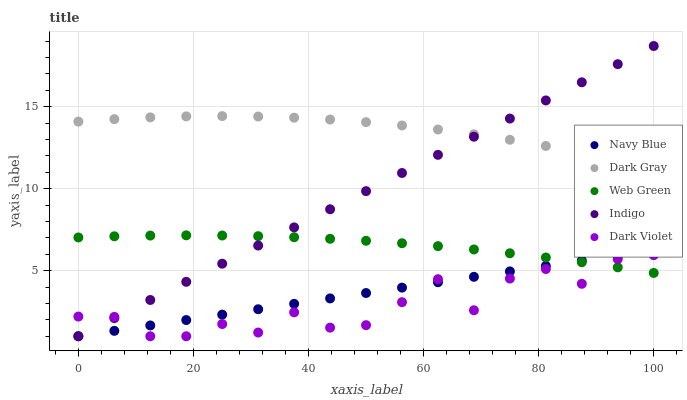Does Dark Violet have the minimum area under the curve?
Answer yes or no. Yes. Does Dark Gray have the maximum area under the curve?
Answer yes or no. Yes. Does Navy Blue have the minimum area under the curve?
Answer yes or no. No. Does Navy Blue have the maximum area under the curve?
Answer yes or no. No. Is Navy Blue the smoothest?
Answer yes or no. Yes. Is Dark Violet the roughest?
Answer yes or no. Yes. Is Indigo the smoothest?
Answer yes or no. No. Is Indigo the roughest?
Answer yes or no. No. Does Navy Blue have the lowest value?
Answer yes or no. Yes. Does Web Green have the lowest value?
Answer yes or no. No. Does Indigo have the highest value?
Answer yes or no. Yes. Does Navy Blue have the highest value?
Answer yes or no. No. Is Navy Blue less than Dark Gray?
Answer yes or no. Yes. Is Dark Gray greater than Dark Violet?
Answer yes or no. Yes. Does Navy Blue intersect Web Green?
Answer yes or no. Yes. Is Navy Blue less than Web Green?
Answer yes or no. No. Is Navy Blue greater than Web Green?
Answer yes or no. No. Does Navy Blue intersect Dark Gray?
Answer yes or no. No. 